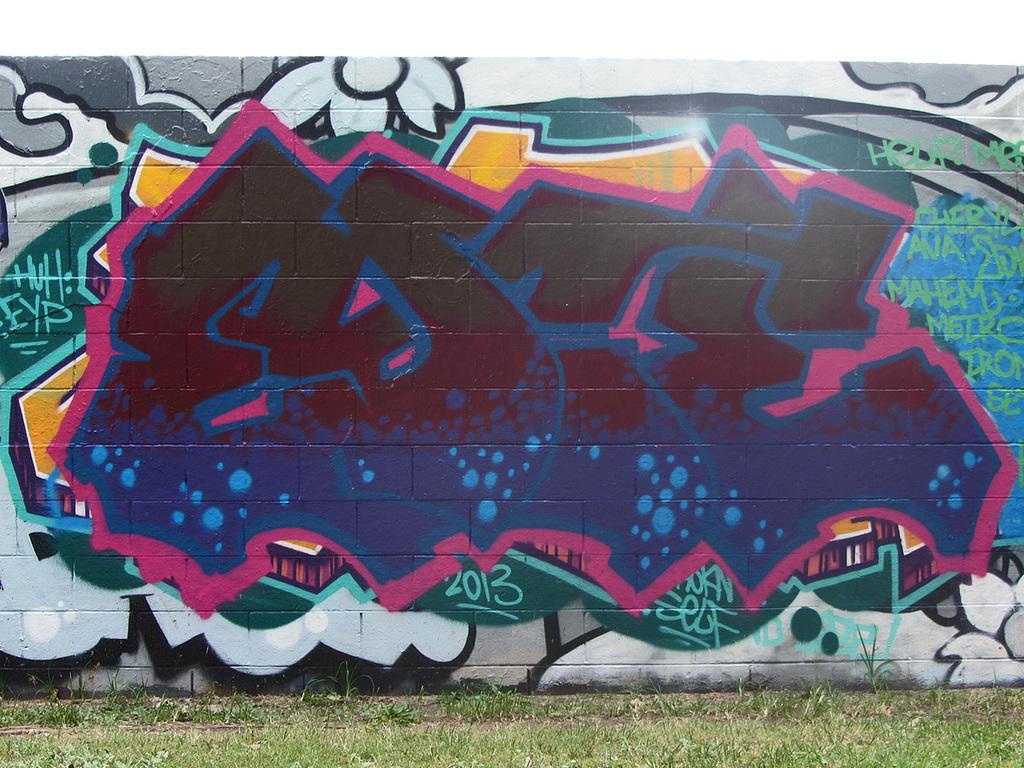What type of surface can be seen in the image? There is a painted wall in the image. What type of vegetation is present on the land in the image? There is grass on the land in the image. What type of dress is being offered to the quince in the image? There is no dress or quince present in the image; it only features a painted wall and grass on the land. 